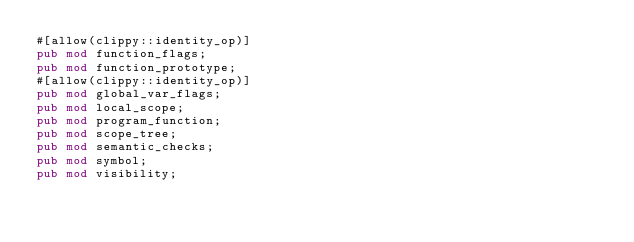<code> <loc_0><loc_0><loc_500><loc_500><_Rust_>#[allow(clippy::identity_op)]
pub mod function_flags;
pub mod function_prototype;
#[allow(clippy::identity_op)]
pub mod global_var_flags;
pub mod local_scope;
pub mod program_function;
pub mod scope_tree;
pub mod semantic_checks;
pub mod symbol;
pub mod visibility;
</code> 